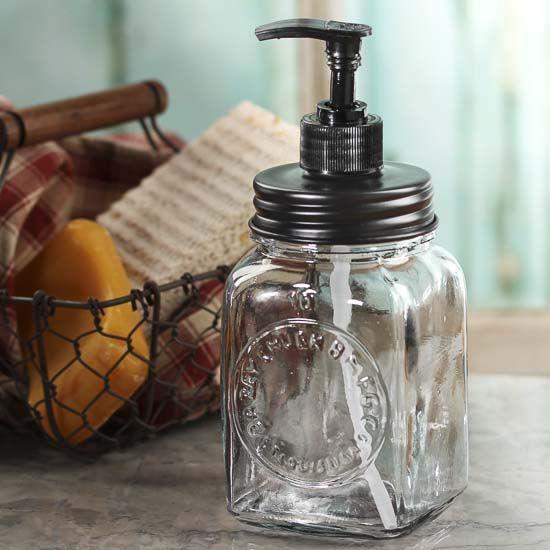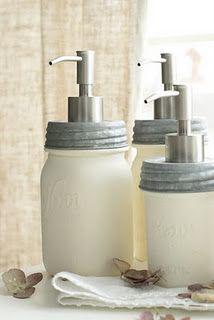The first image is the image on the left, the second image is the image on the right. Given the left and right images, does the statement "An image shows a pair of pump-top dispensers in a wire caddy with an oval medallion on the front, and the other image includes a jar of toothbrushes." hold true? Answer yes or no. No. The first image is the image on the left, the second image is the image on the right. Considering the images on both sides, is "The left image contains exactly two glass jar dispensers." valid? Answer yes or no. No. 